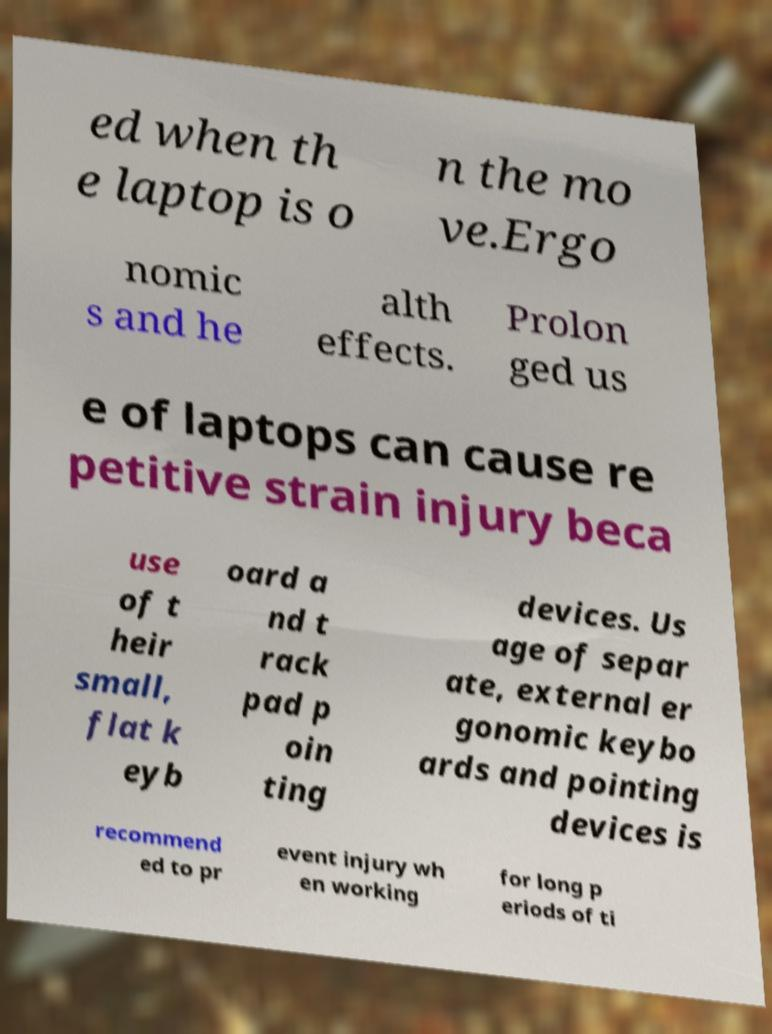Please read and relay the text visible in this image. What does it say? ed when th e laptop is o n the mo ve.Ergo nomic s and he alth effects. Prolon ged us e of laptops can cause re petitive strain injury beca use of t heir small, flat k eyb oard a nd t rack pad p oin ting devices. Us age of separ ate, external er gonomic keybo ards and pointing devices is recommend ed to pr event injury wh en working for long p eriods of ti 